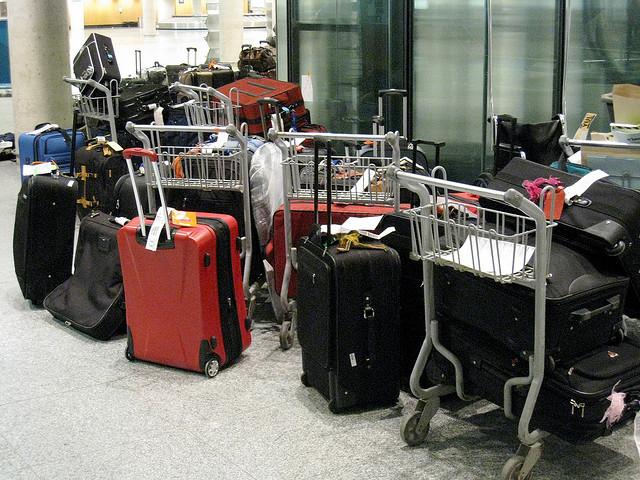Where is the red suitcase?
Be succinct. To left. What area of the airport was this picture taken?
Short answer required. Baggage claim. How many white columns are in the photo?
Answer briefly. 1. Is the handle of the red suitcase up?
Quick response, please. Yes. 